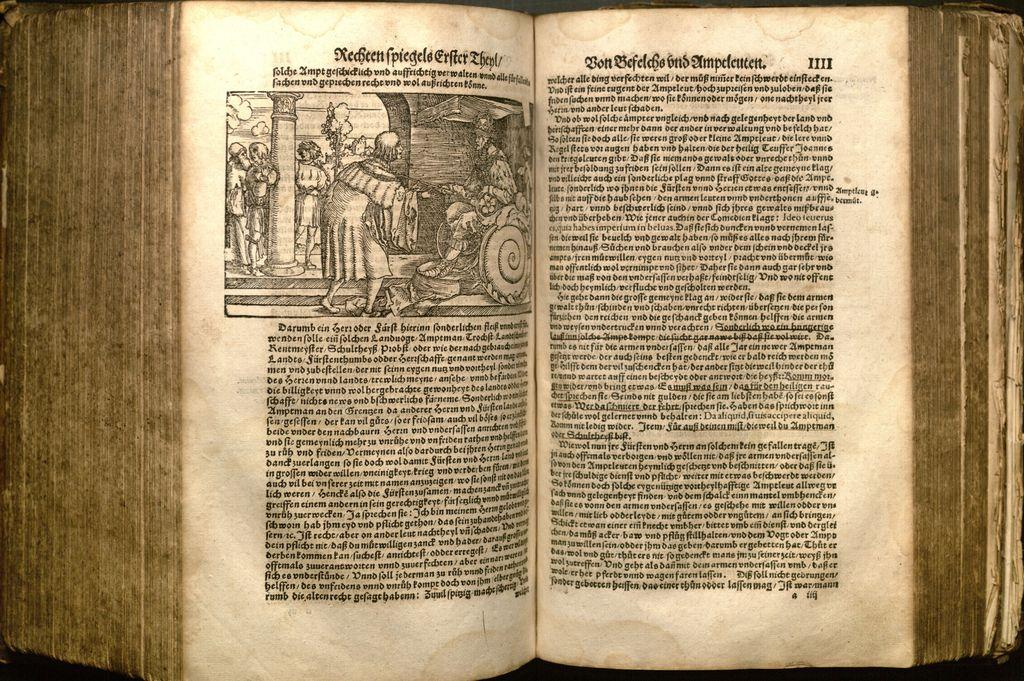What is the main subject of the image? The main subject of the image is a picture. Can you describe the contents of the picture? The provided facts do not give enough information to describe the contents of the picture. What else is present in the image besides the picture? There is text in a book in the image. What might the text in the book be about? The provided facts do not give enough information to determine the topic of the text in the book. What type of magic is being performed by the building in the image? There is no building present in the image, and therefore no magic being performed. What shape is the shape-shifting creature in the image? There is no shape-shifting creature present in the image. 